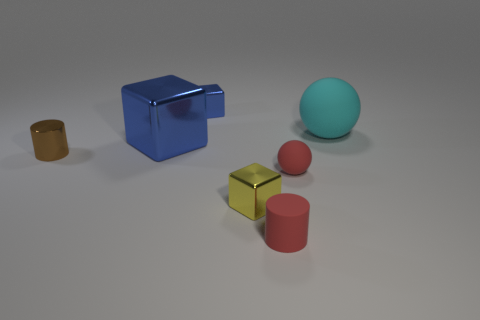Is there anything else that has the same material as the small blue object?
Give a very brief answer. Yes. There is a block that is the same color as the big metal thing; what size is it?
Keep it short and to the point. Small. There is a cylinder that is the same size as the brown shiny thing; what color is it?
Your answer should be very brief. Red. Does the large rubber ball have the same color as the big shiny object?
Your answer should be very brief. No. How many things are behind the large metallic block and on the right side of the yellow block?
Your answer should be very brief. 1. What material is the large block?
Provide a succinct answer. Metal. Is there anything else of the same color as the small metallic cylinder?
Make the answer very short. No. Is the material of the tiny red ball the same as the red cylinder?
Offer a very short reply. Yes. How many metallic objects are right of the tiny red thing that is right of the tiny red object left of the red rubber ball?
Your answer should be very brief. 0. What number of blue objects are there?
Ensure brevity in your answer.  2. 